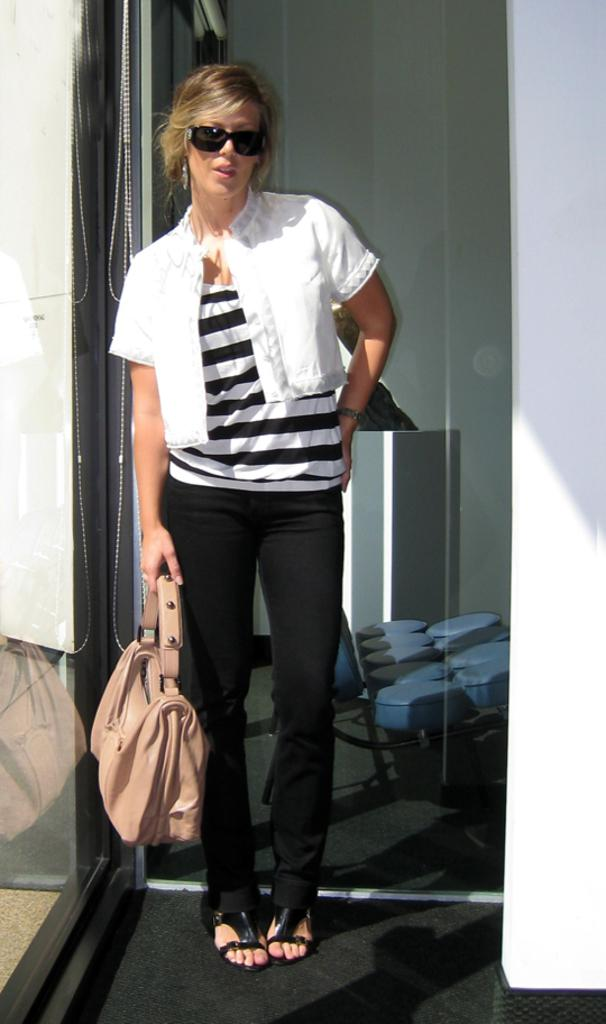What is the person in the image doing? The person is standing on the floor in the image. What is the person holding in the image? The person is holding a bag. What can be seen in the background of the image? There are glasses in the background of the image. What is visible through the glasses in the image? Objects on the ground are visible through the glasses. What type of rhythm is the person creating with the cord in the image? There is no cord present in the image, and therefore no rhythm can be created. 